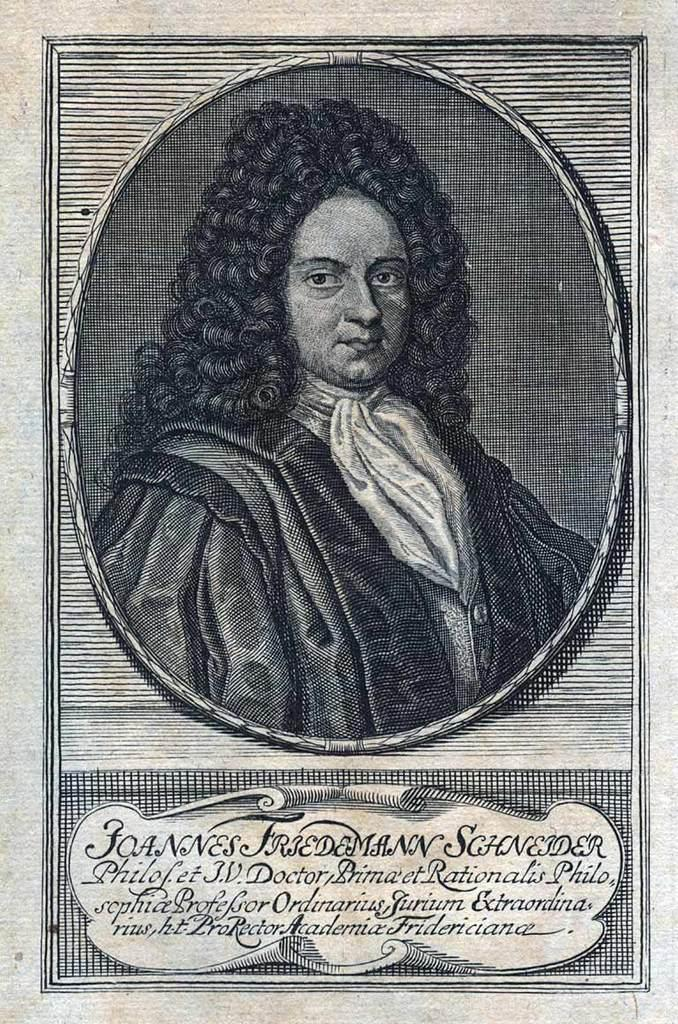<image>
Write a terse but informative summary of the picture. An old poster with a man on it that says Joannes Friedemann Schneider on it. 